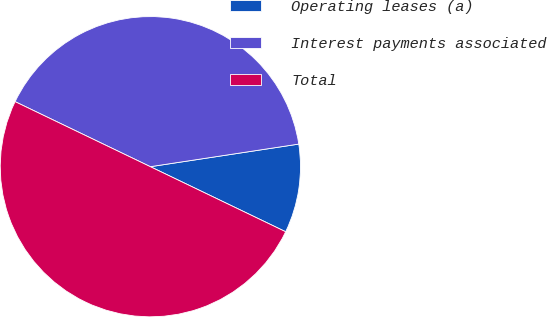<chart> <loc_0><loc_0><loc_500><loc_500><pie_chart><fcel>Operating leases (a)<fcel>Interest payments associated<fcel>Total<nl><fcel>9.54%<fcel>40.46%<fcel>50.0%<nl></chart> 